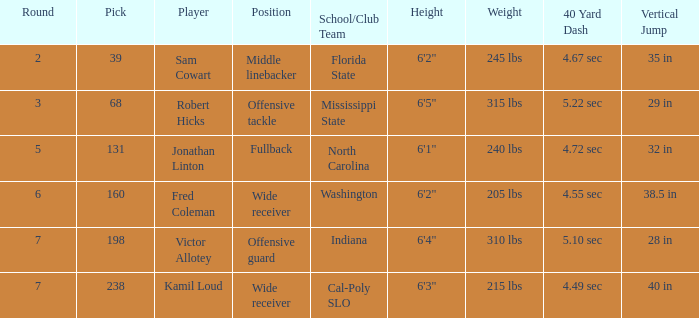Which Player has a Round smaller than 5, and a School/Club Team of florida state? Sam Cowart. Can you give me this table as a dict? {'header': ['Round', 'Pick', 'Player', 'Position', 'School/Club Team', 'Height', 'Weight', '40 Yard Dash', 'Vertical Jump '], 'rows': [['2', '39', 'Sam Cowart', 'Middle linebacker', 'Florida State', '6\'2"', '245 lbs', '4.67 sec', '35 in'], ['3', '68', 'Robert Hicks', 'Offensive tackle', 'Mississippi State', '6\'5"', '315 lbs', '5.22 sec', '29 in'], ['5', '131', 'Jonathan Linton', 'Fullback', 'North Carolina', '6\'1"', '240 lbs', '4.72 sec', '32 in'], ['6', '160', 'Fred Coleman', 'Wide receiver', 'Washington', '6\'2"', '205 lbs', '4.55 sec', '38.5 in'], ['7', '198', 'Victor Allotey', 'Offensive guard', 'Indiana', '6\'4"', '310 lbs', '5.10 sec', '28 in'], ['7', '238', 'Kamil Loud', 'Wide receiver', 'Cal-Poly SLO', '6\'3"', '215 lbs', '4.49 sec', '40 in']]} 